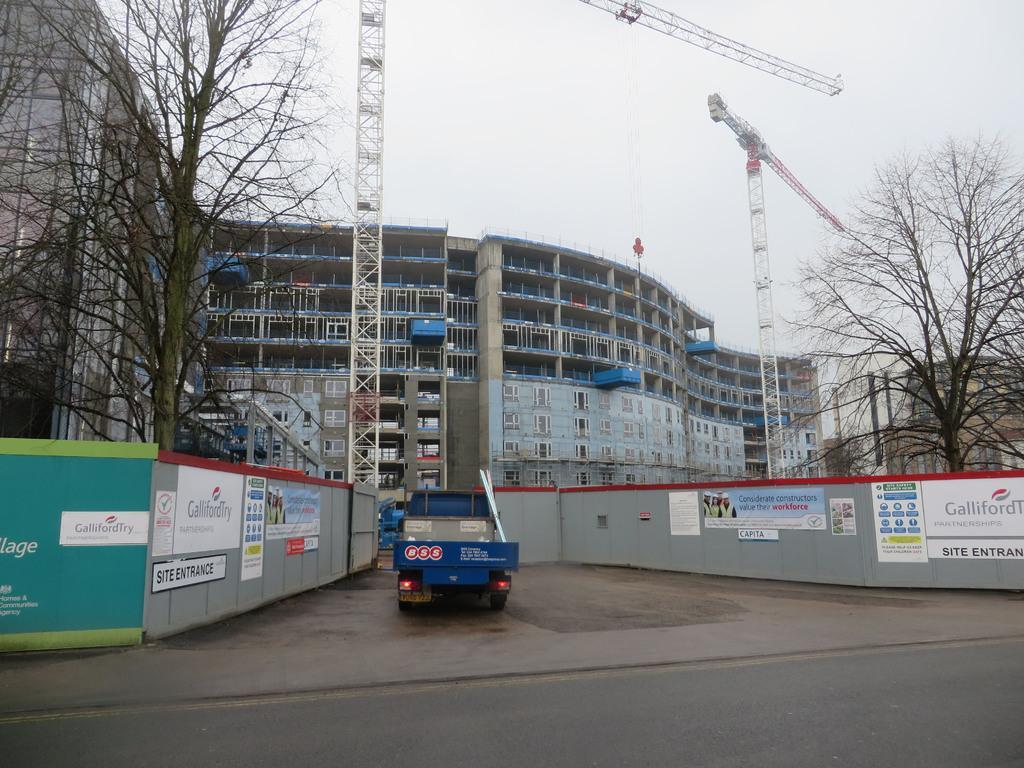How would you summarize this image in a sentence or two? In this picture I can see buildings, trees and couple of cranes and I can see a truck and a cloudy sky and I can see few boards with some text. 